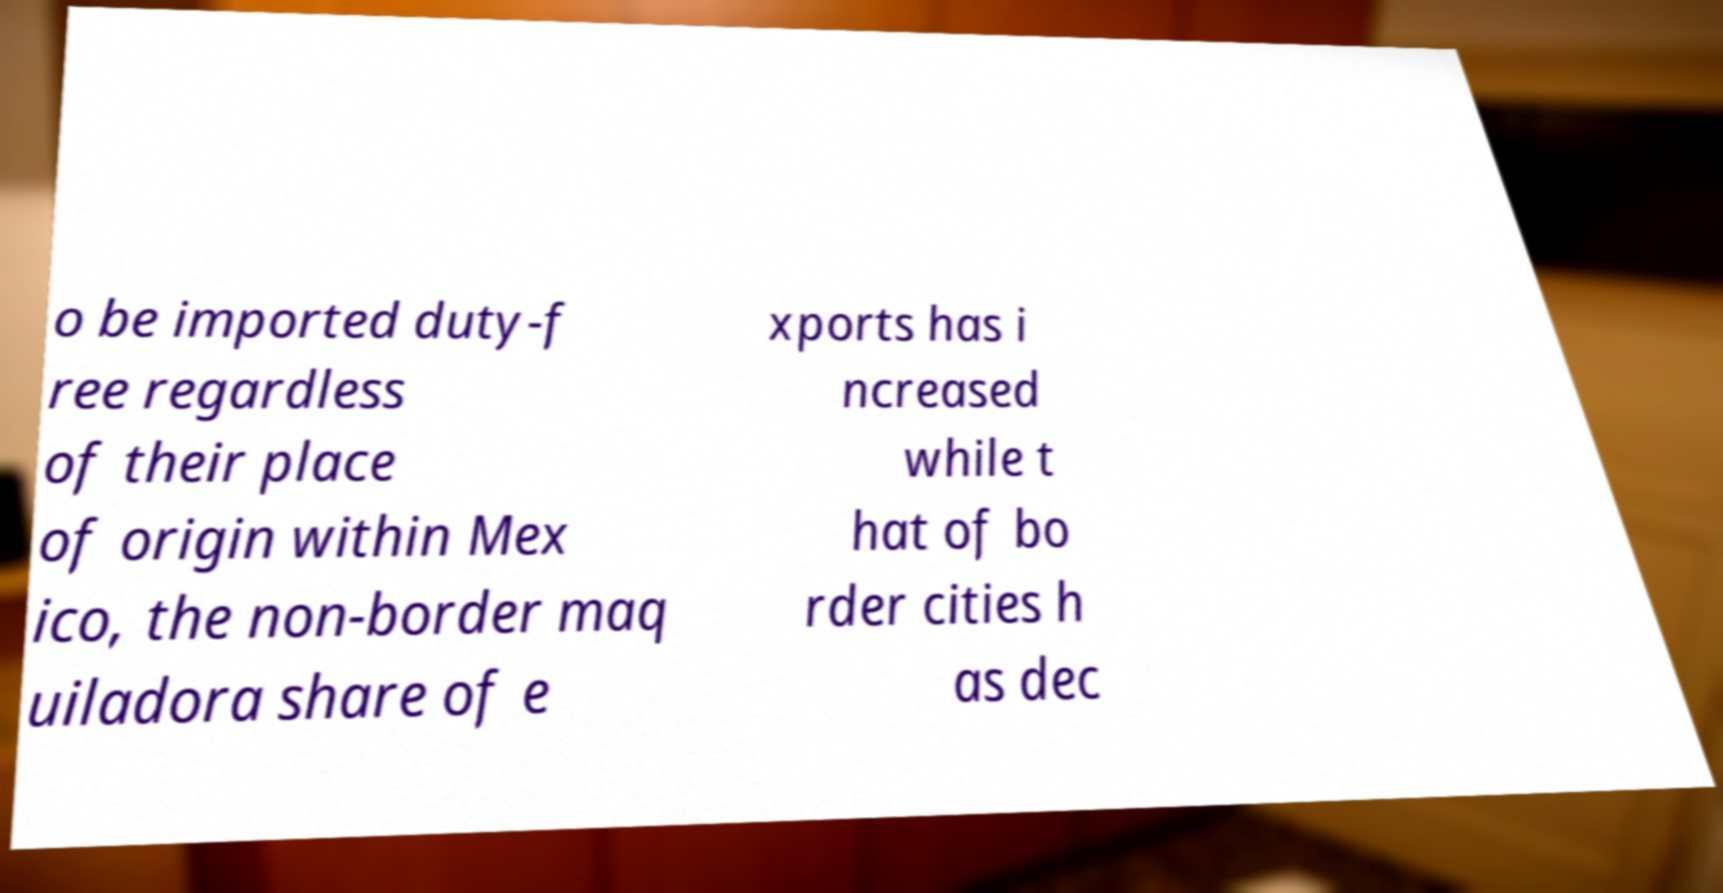Can you read and provide the text displayed in the image?This photo seems to have some interesting text. Can you extract and type it out for me? o be imported duty-f ree regardless of their place of origin within Mex ico, the non-border maq uiladora share of e xports has i ncreased while t hat of bo rder cities h as dec 